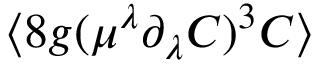Convert formula to latex. <formula><loc_0><loc_0><loc_500><loc_500>\langle 8 g ( \mu ^ { \lambda } \partial _ { \lambda } { C } ) ^ { 3 } C \rangle</formula> 